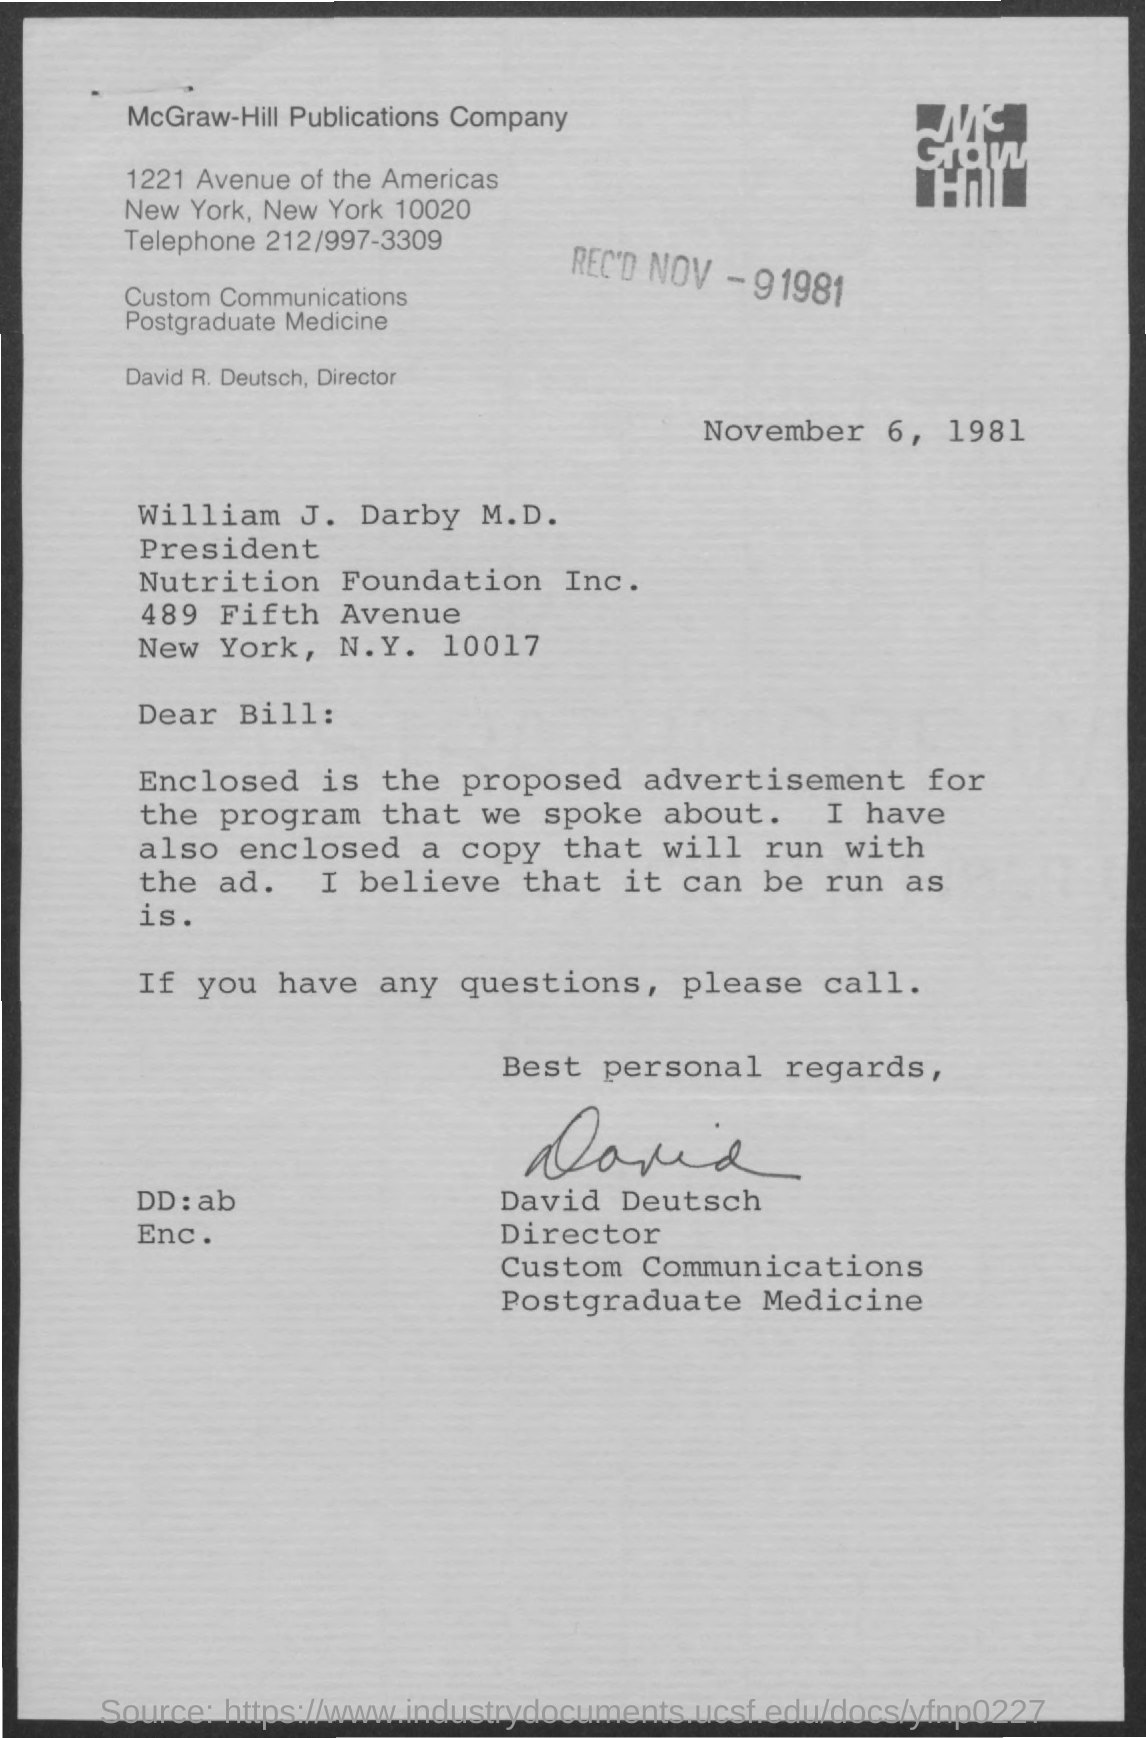Give some essential details in this illustration. The date of the document is November 6, 1981. 